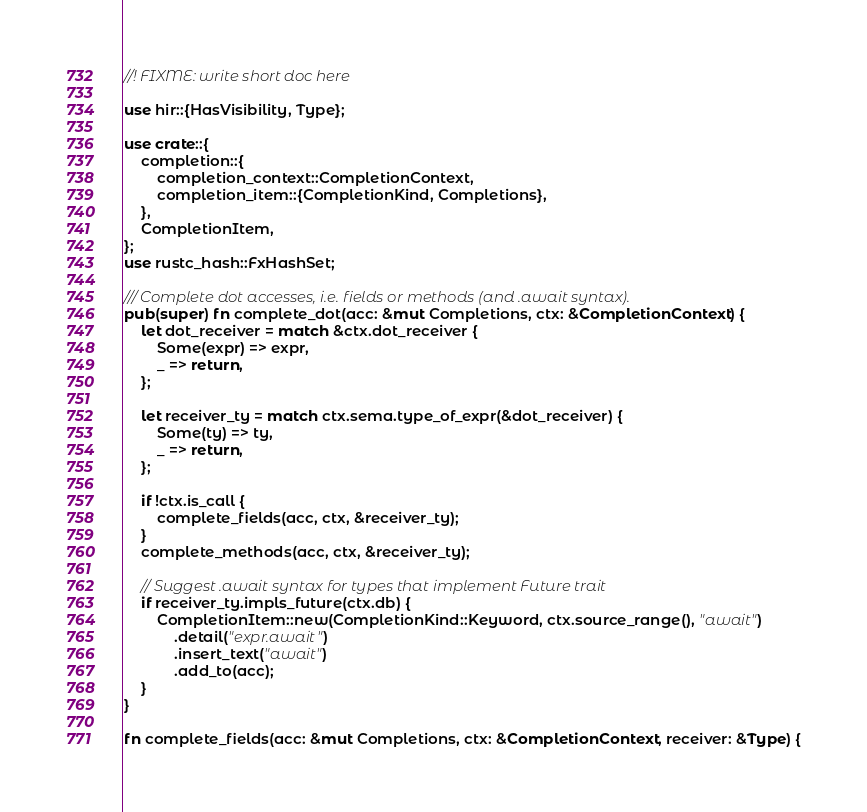<code> <loc_0><loc_0><loc_500><loc_500><_Rust_>//! FIXME: write short doc here

use hir::{HasVisibility, Type};

use crate::{
    completion::{
        completion_context::CompletionContext,
        completion_item::{CompletionKind, Completions},
    },
    CompletionItem,
};
use rustc_hash::FxHashSet;

/// Complete dot accesses, i.e. fields or methods (and .await syntax).
pub(super) fn complete_dot(acc: &mut Completions, ctx: &CompletionContext) {
    let dot_receiver = match &ctx.dot_receiver {
        Some(expr) => expr,
        _ => return,
    };

    let receiver_ty = match ctx.sema.type_of_expr(&dot_receiver) {
        Some(ty) => ty,
        _ => return,
    };

    if !ctx.is_call {
        complete_fields(acc, ctx, &receiver_ty);
    }
    complete_methods(acc, ctx, &receiver_ty);

    // Suggest .await syntax for types that implement Future trait
    if receiver_ty.impls_future(ctx.db) {
        CompletionItem::new(CompletionKind::Keyword, ctx.source_range(), "await")
            .detail("expr.await")
            .insert_text("await")
            .add_to(acc);
    }
}

fn complete_fields(acc: &mut Completions, ctx: &CompletionContext, receiver: &Type) {</code> 